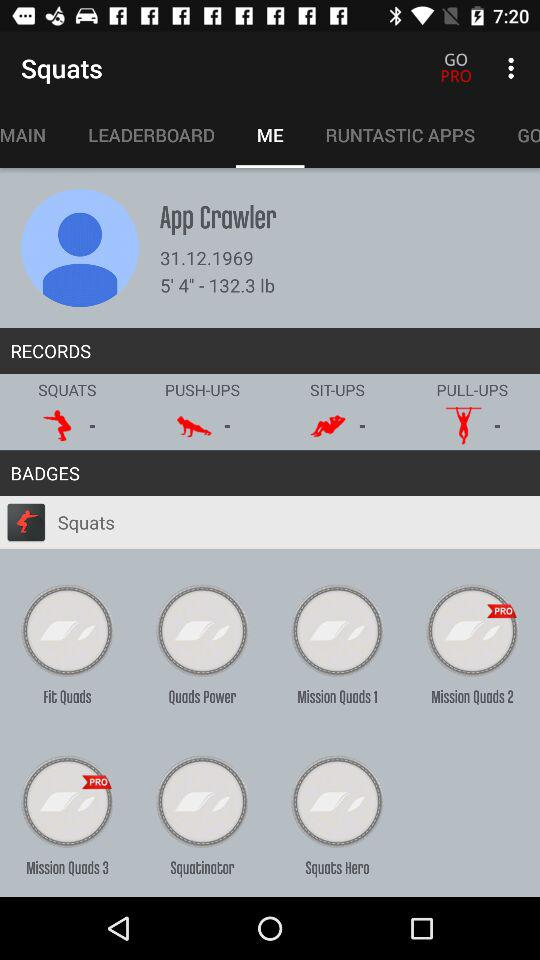What exercises' records are available? The records are available for "SQUATS", "PUSH-UPS", "SIT-UPS" and "PULL-UPS" exercises. 